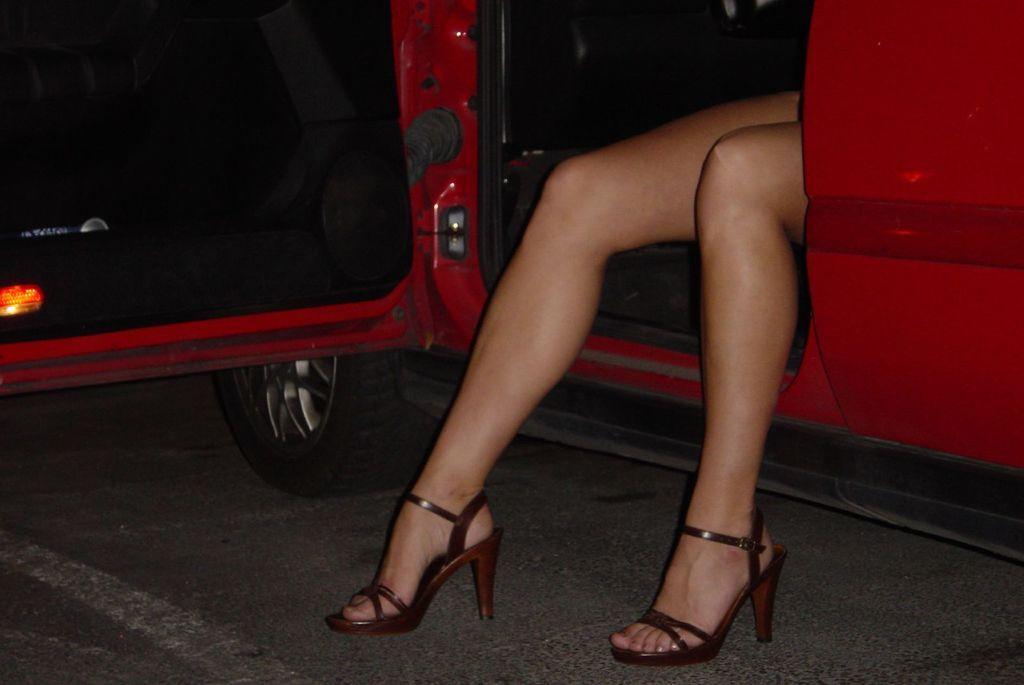How would you summarize this image in a sentence or two? In this image there is a red vehicle on a road, a person is sitting in a vehicle and she is wearing a heels. 